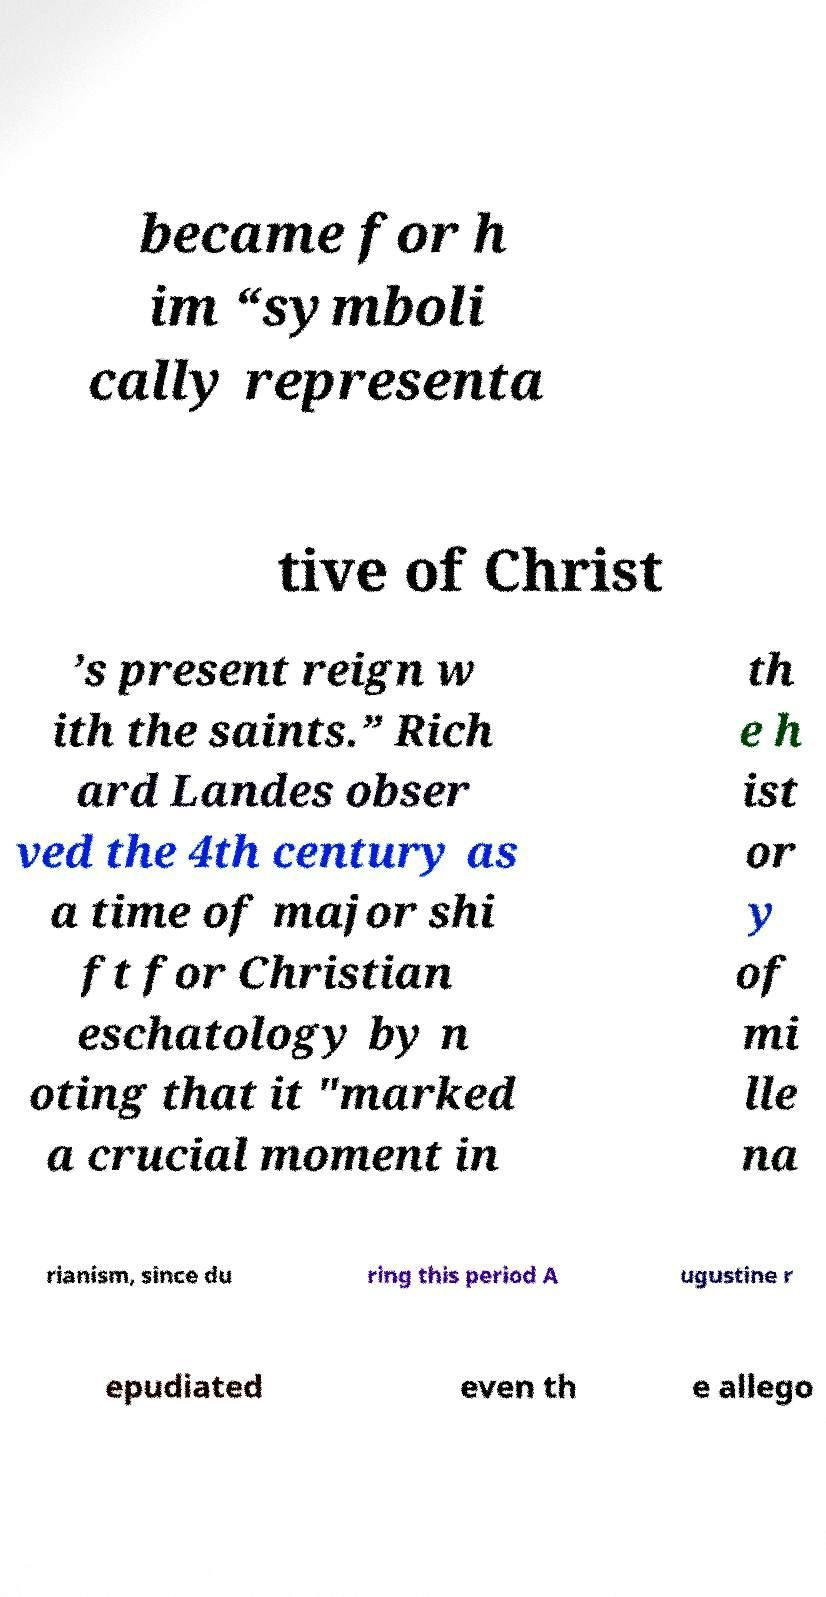Please read and relay the text visible in this image. What does it say? became for h im “symboli cally representa tive of Christ ’s present reign w ith the saints.” Rich ard Landes obser ved the 4th century as a time of major shi ft for Christian eschatology by n oting that it "marked a crucial moment in th e h ist or y of mi lle na rianism, since du ring this period A ugustine r epudiated even th e allego 